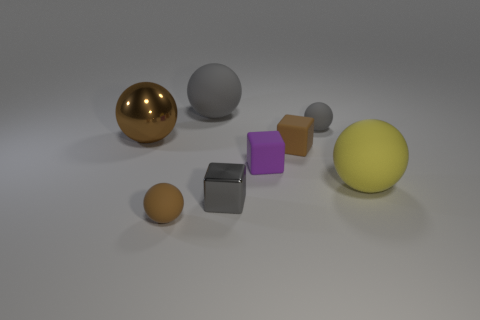Subtract 1 balls. How many balls are left? 4 Add 1 cyan cubes. How many objects exist? 9 Subtract all spheres. How many objects are left? 3 Add 5 large brown spheres. How many large brown spheres are left? 6 Add 6 purple objects. How many purple objects exist? 7 Subtract 0 blue blocks. How many objects are left? 8 Subtract all tiny matte balls. Subtract all small matte spheres. How many objects are left? 4 